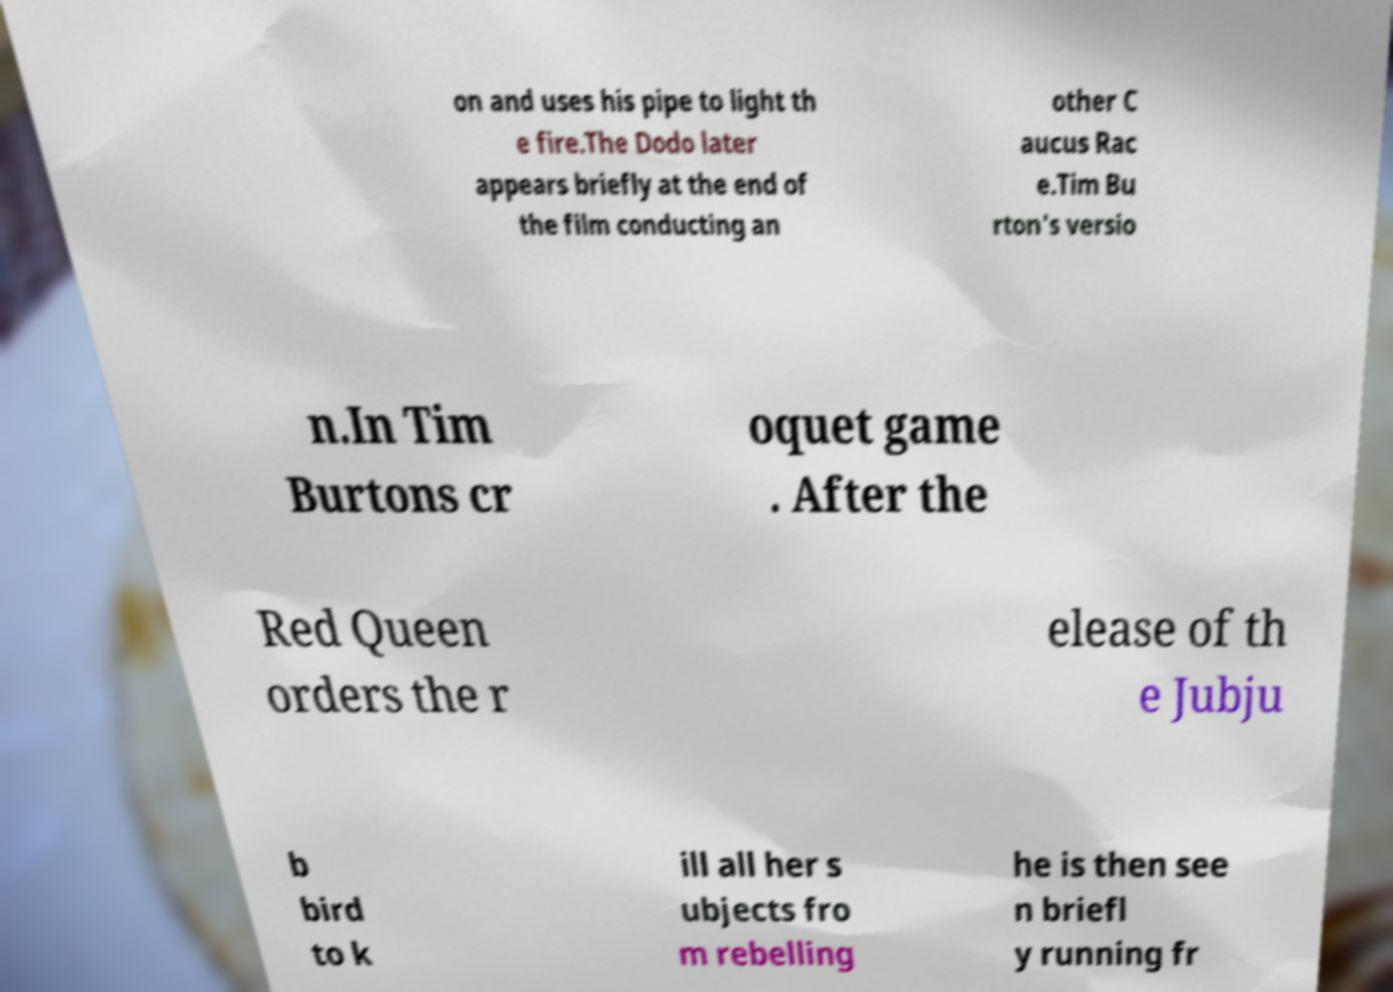Can you accurately transcribe the text from the provided image for me? on and uses his pipe to light th e fire.The Dodo later appears briefly at the end of the film conducting an other C aucus Rac e.Tim Bu rton's versio n.In Tim Burtons cr oquet game . After the Red Queen orders the r elease of th e Jubju b bird to k ill all her s ubjects fro m rebelling he is then see n briefl y running fr 